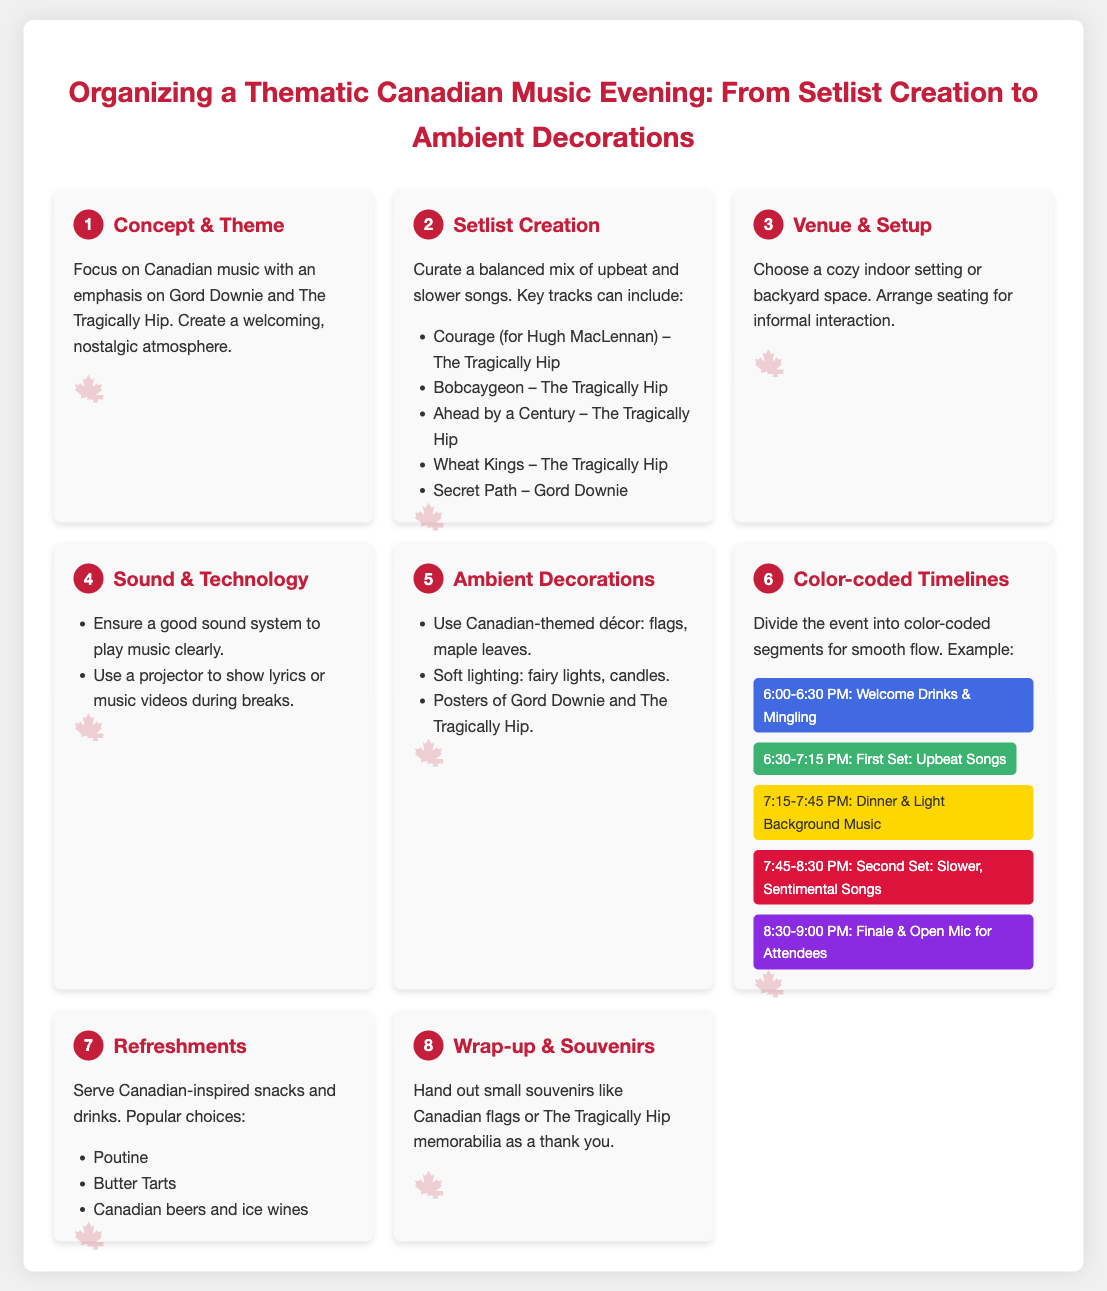What is the main theme of the music evening? The theme focuses on Canadian music, particularly highlighting Gord Downie and The Tragically Hip.
Answer: Canadian music What song is suggested for the first set? The infographic mentions several key tracks, one of which is included for the first set.
Answer: Upbeat Songs How long is the welcome drinks segment? The timeline shows the duration allotted for the welcome drinks and mingling.
Answer: 30 minutes What is a recommended ambient decoration? The document lists various decorations, one example being the use of flags.
Answer: Flags What type of refreshments are suggested? The document provides examples of snacks and drinks that can be served.
Answer: Poutine What is the starting time for the music evening? The timeline lists specific time slots, revealing the start of the event.
Answer: 6:00 PM How many steps are there in the organizing process? The infographic outlines the process in specific numbered steps.
Answer: 8 steps What should be provided during the finale segment? The timeline indicates an interactive element during the last segment.
Answer: Open Mic What color represents the dinner segment in the timeline? The timeline uses colors to distinguish between segments, including dinner.
Answer: Yellow 